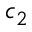<formula> <loc_0><loc_0><loc_500><loc_500>c _ { 2 }</formula> 